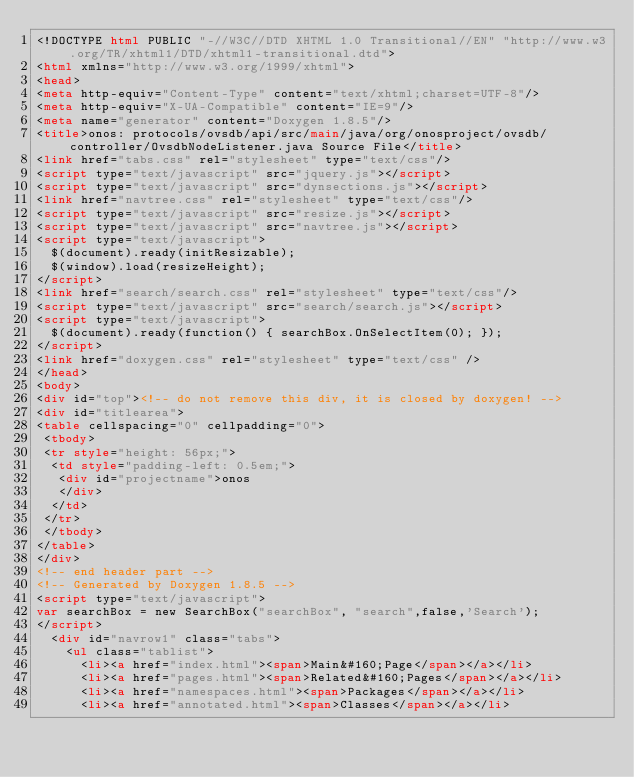<code> <loc_0><loc_0><loc_500><loc_500><_HTML_><!DOCTYPE html PUBLIC "-//W3C//DTD XHTML 1.0 Transitional//EN" "http://www.w3.org/TR/xhtml1/DTD/xhtml1-transitional.dtd">
<html xmlns="http://www.w3.org/1999/xhtml">
<head>
<meta http-equiv="Content-Type" content="text/xhtml;charset=UTF-8"/>
<meta http-equiv="X-UA-Compatible" content="IE=9"/>
<meta name="generator" content="Doxygen 1.8.5"/>
<title>onos: protocols/ovsdb/api/src/main/java/org/onosproject/ovsdb/controller/OvsdbNodeListener.java Source File</title>
<link href="tabs.css" rel="stylesheet" type="text/css"/>
<script type="text/javascript" src="jquery.js"></script>
<script type="text/javascript" src="dynsections.js"></script>
<link href="navtree.css" rel="stylesheet" type="text/css"/>
<script type="text/javascript" src="resize.js"></script>
<script type="text/javascript" src="navtree.js"></script>
<script type="text/javascript">
  $(document).ready(initResizable);
  $(window).load(resizeHeight);
</script>
<link href="search/search.css" rel="stylesheet" type="text/css"/>
<script type="text/javascript" src="search/search.js"></script>
<script type="text/javascript">
  $(document).ready(function() { searchBox.OnSelectItem(0); });
</script>
<link href="doxygen.css" rel="stylesheet" type="text/css" />
</head>
<body>
<div id="top"><!-- do not remove this div, it is closed by doxygen! -->
<div id="titlearea">
<table cellspacing="0" cellpadding="0">
 <tbody>
 <tr style="height: 56px;">
  <td style="padding-left: 0.5em;">
   <div id="projectname">onos
   </div>
  </td>
 </tr>
 </tbody>
</table>
</div>
<!-- end header part -->
<!-- Generated by Doxygen 1.8.5 -->
<script type="text/javascript">
var searchBox = new SearchBox("searchBox", "search",false,'Search');
</script>
  <div id="navrow1" class="tabs">
    <ul class="tablist">
      <li><a href="index.html"><span>Main&#160;Page</span></a></li>
      <li><a href="pages.html"><span>Related&#160;Pages</span></a></li>
      <li><a href="namespaces.html"><span>Packages</span></a></li>
      <li><a href="annotated.html"><span>Classes</span></a></li></code> 